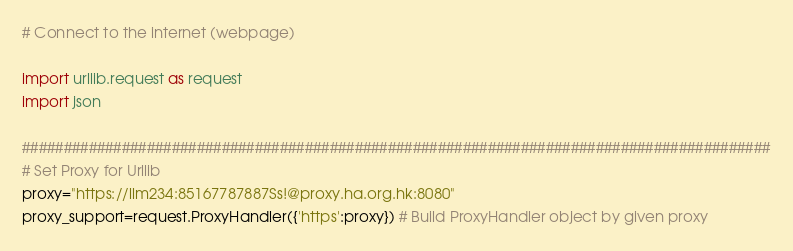<code> <loc_0><loc_0><loc_500><loc_500><_Python_># Connect to the internet (webpage)

import urllib.request as request
import json

##########################################################################################
# Set Proxy for Urllib
proxy="https://llm234:85167787887Ss!@proxy.ha.org.hk:8080"
proxy_support=request.ProxyHandler({'https':proxy}) # Build ProxyHandler object by given proxy</code> 